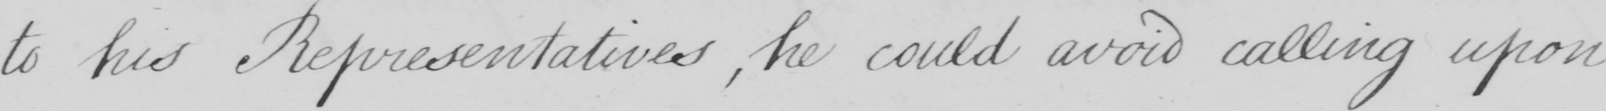Transcribe the text shown in this historical manuscript line. to his Representatives , he could avoid calling upon 